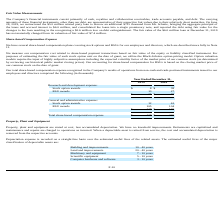According to Acura Pharmaceuticals's financial document, How is share-based compensation expense measured? We measure our compensation cost related to share-based payment transactions based on fair value of the equity or liability classified instrument.. The document states: "We measure our compensation cost related to share-based payment transactions based on fair value of the equity or liability classified instrument. For..." Also, What are the types of share-based compensation plans? We have several share-based compensation plans covering stock options and RSUs for our employees and directors. The document states: "of $7.4 million. Share-based Compensation Expense We have several share-based compensation plans covering stock options and RSUs for our employees and..." Also, What was the total share-based compensation in 2018? According to the financial document, 138 (in thousands). The relevant text states: "Total share-based compensation expense $ 138 $ 230..." Also, can you calculate: How much did the stock-based compensation expense in the general and administrative operations decreased from 2018 to 2019? Based on the calculation: 165 - 117 , the result is 48 (in thousands). This is based on the information: "$ 117 $ 165 $ 117 $ 165..." The key data points involved are: 117, 165. Also, can you calculate: How much percent did the total share-based compensation decreased from 2018 to 2019? To answer this question, I need to perform calculations using the financial data. The calculation is: (230 - 138) / 138 , which equals 66.67 (percentage). This is based on the information: "Total share-based compensation expense $ 138 $ 230 Total share-based compensation expense $ 138 $ 230..." The key data points involved are: 138, 230. Also, can you calculate: What proportion of the total stock-based compensation expense is made up from the research and development operations in 2019? Based on the calculation: 21/138 , the result is 15.22 (percentage). This is based on the information: "Total share-based compensation expense $ 138 $ 230 $ 21 $ 65..." The key data points involved are: 138, 21. 